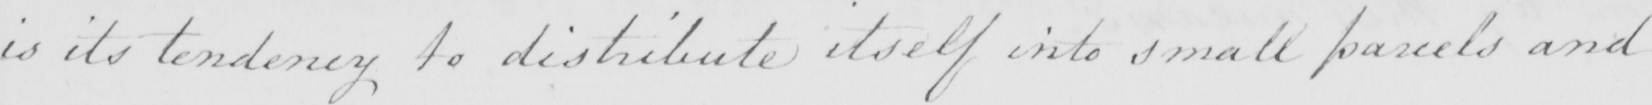Can you read and transcribe this handwriting? is its tendency to distribute itself into small parcels and 